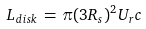Convert formula to latex. <formula><loc_0><loc_0><loc_500><loc_500>L _ { d i s k } \, = \, \pi ( 3 R _ { s } ) ^ { 2 } U _ { r } c</formula> 